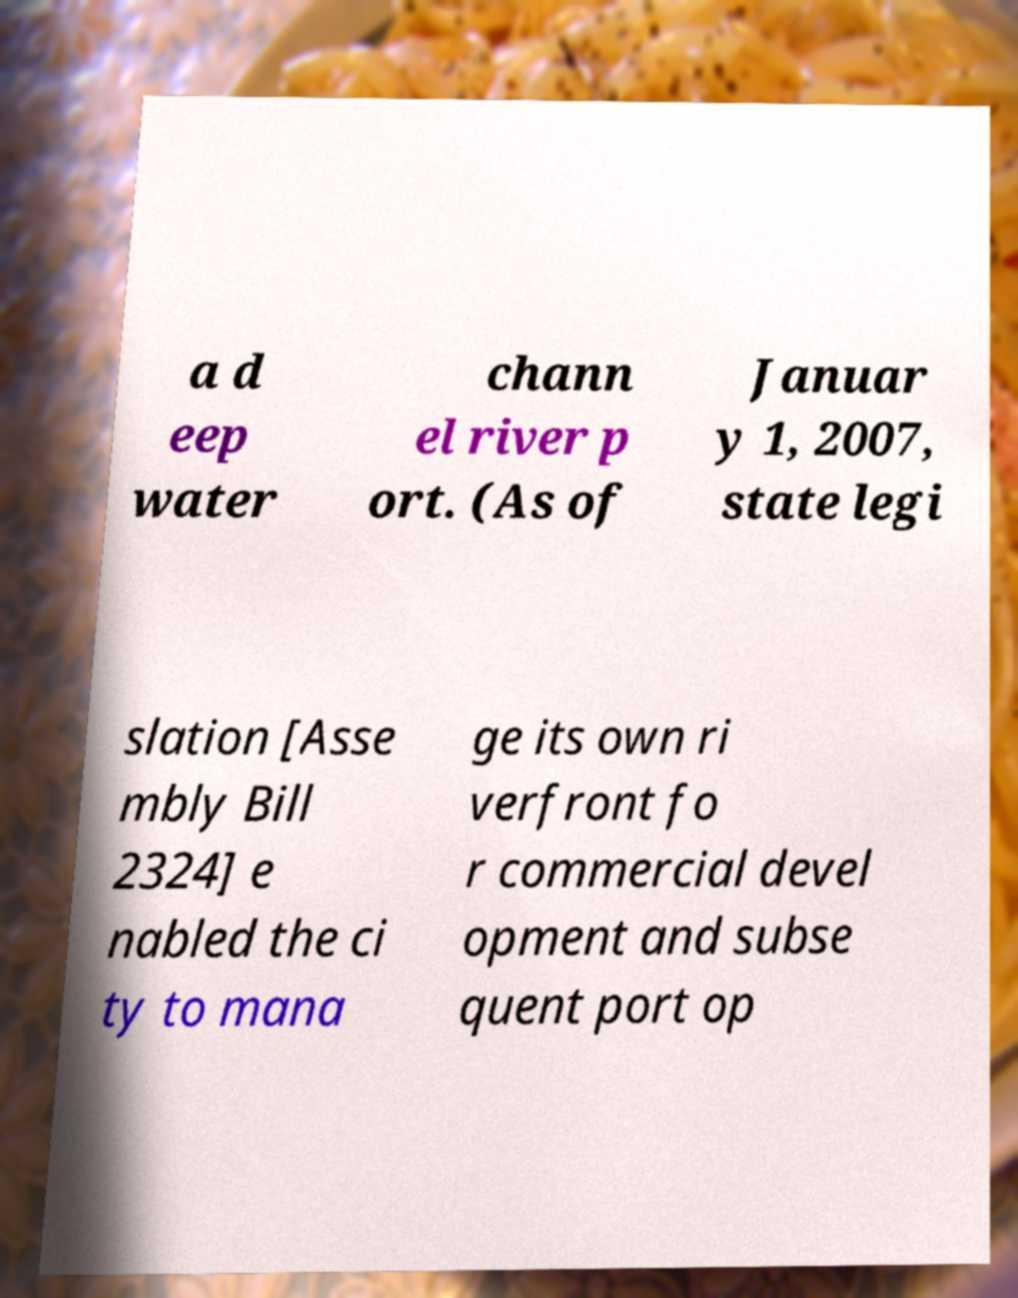Can you read and provide the text displayed in the image?This photo seems to have some interesting text. Can you extract and type it out for me? a d eep water chann el river p ort. (As of Januar y 1, 2007, state legi slation [Asse mbly Bill 2324] e nabled the ci ty to mana ge its own ri verfront fo r commercial devel opment and subse quent port op 